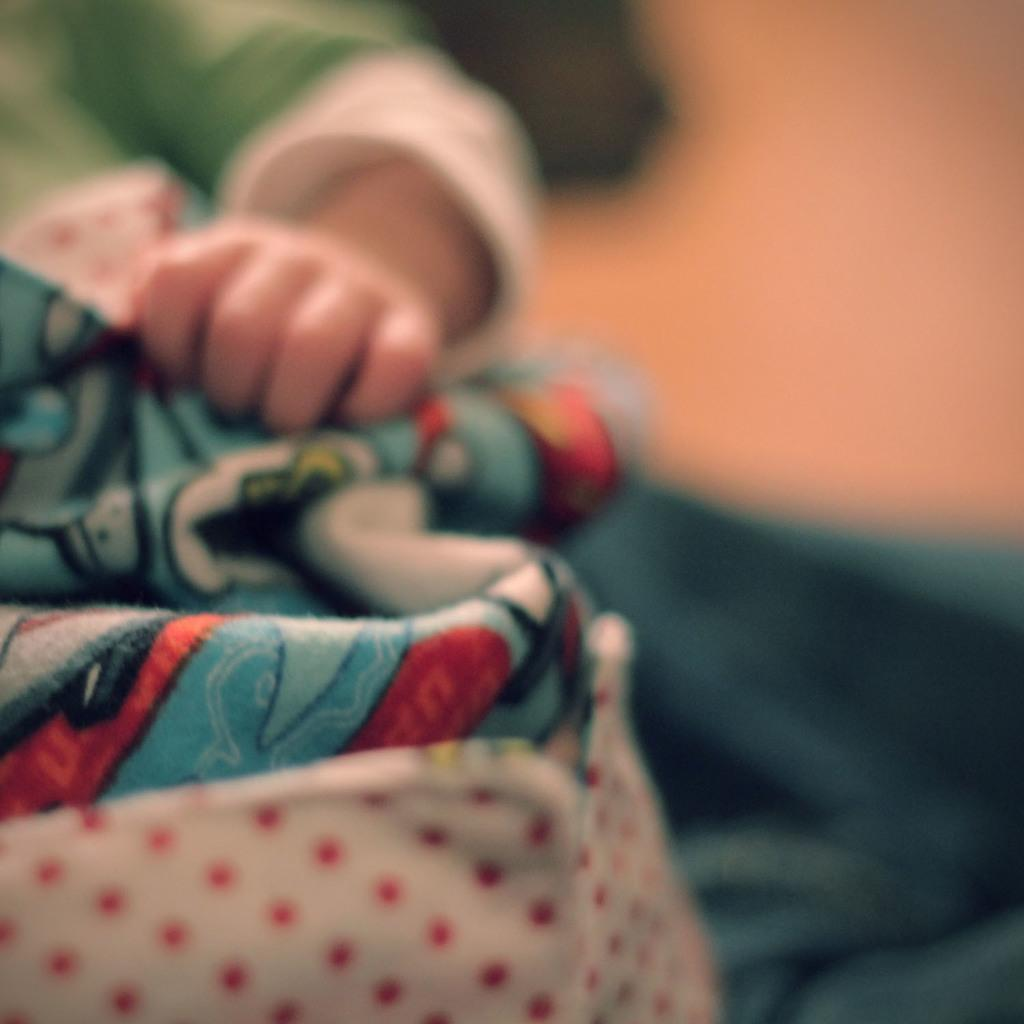What part of a person is visible in the image? There is a person's hand visible in the image. What object is present in the image that might be used for warmth or comfort? There is a blanket in the image. What type of jam is being spread on the hall in the image? There is no jam or hall present in the image; only a person's hand and a blanket are visible. 